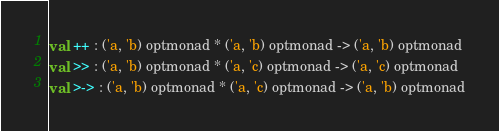Convert code to text. <code><loc_0><loc_0><loc_500><loc_500><_SML_>val ++ : ('a, 'b) optmonad * ('a, 'b) optmonad -> ('a, 'b) optmonad
val >> : ('a, 'b) optmonad * ('a, 'c) optmonad -> ('a, 'c) optmonad
val >-> : ('a, 'b) optmonad * ('a, 'c) optmonad -> ('a, 'b) optmonad</code> 